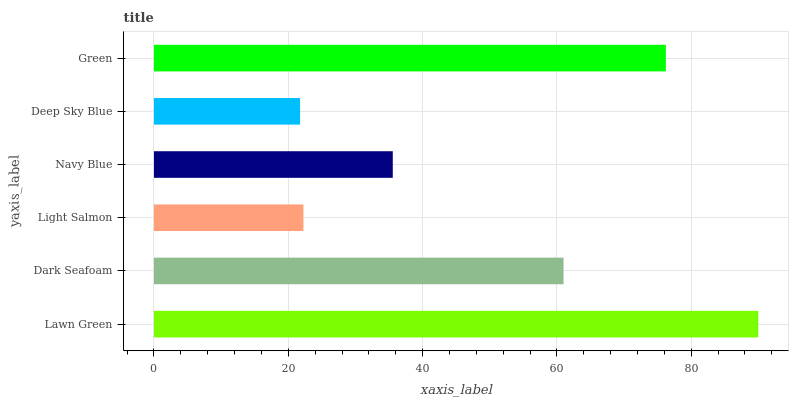Is Deep Sky Blue the minimum?
Answer yes or no. Yes. Is Lawn Green the maximum?
Answer yes or no. Yes. Is Dark Seafoam the minimum?
Answer yes or no. No. Is Dark Seafoam the maximum?
Answer yes or no. No. Is Lawn Green greater than Dark Seafoam?
Answer yes or no. Yes. Is Dark Seafoam less than Lawn Green?
Answer yes or no. Yes. Is Dark Seafoam greater than Lawn Green?
Answer yes or no. No. Is Lawn Green less than Dark Seafoam?
Answer yes or no. No. Is Dark Seafoam the high median?
Answer yes or no. Yes. Is Navy Blue the low median?
Answer yes or no. Yes. Is Green the high median?
Answer yes or no. No. Is Dark Seafoam the low median?
Answer yes or no. No. 